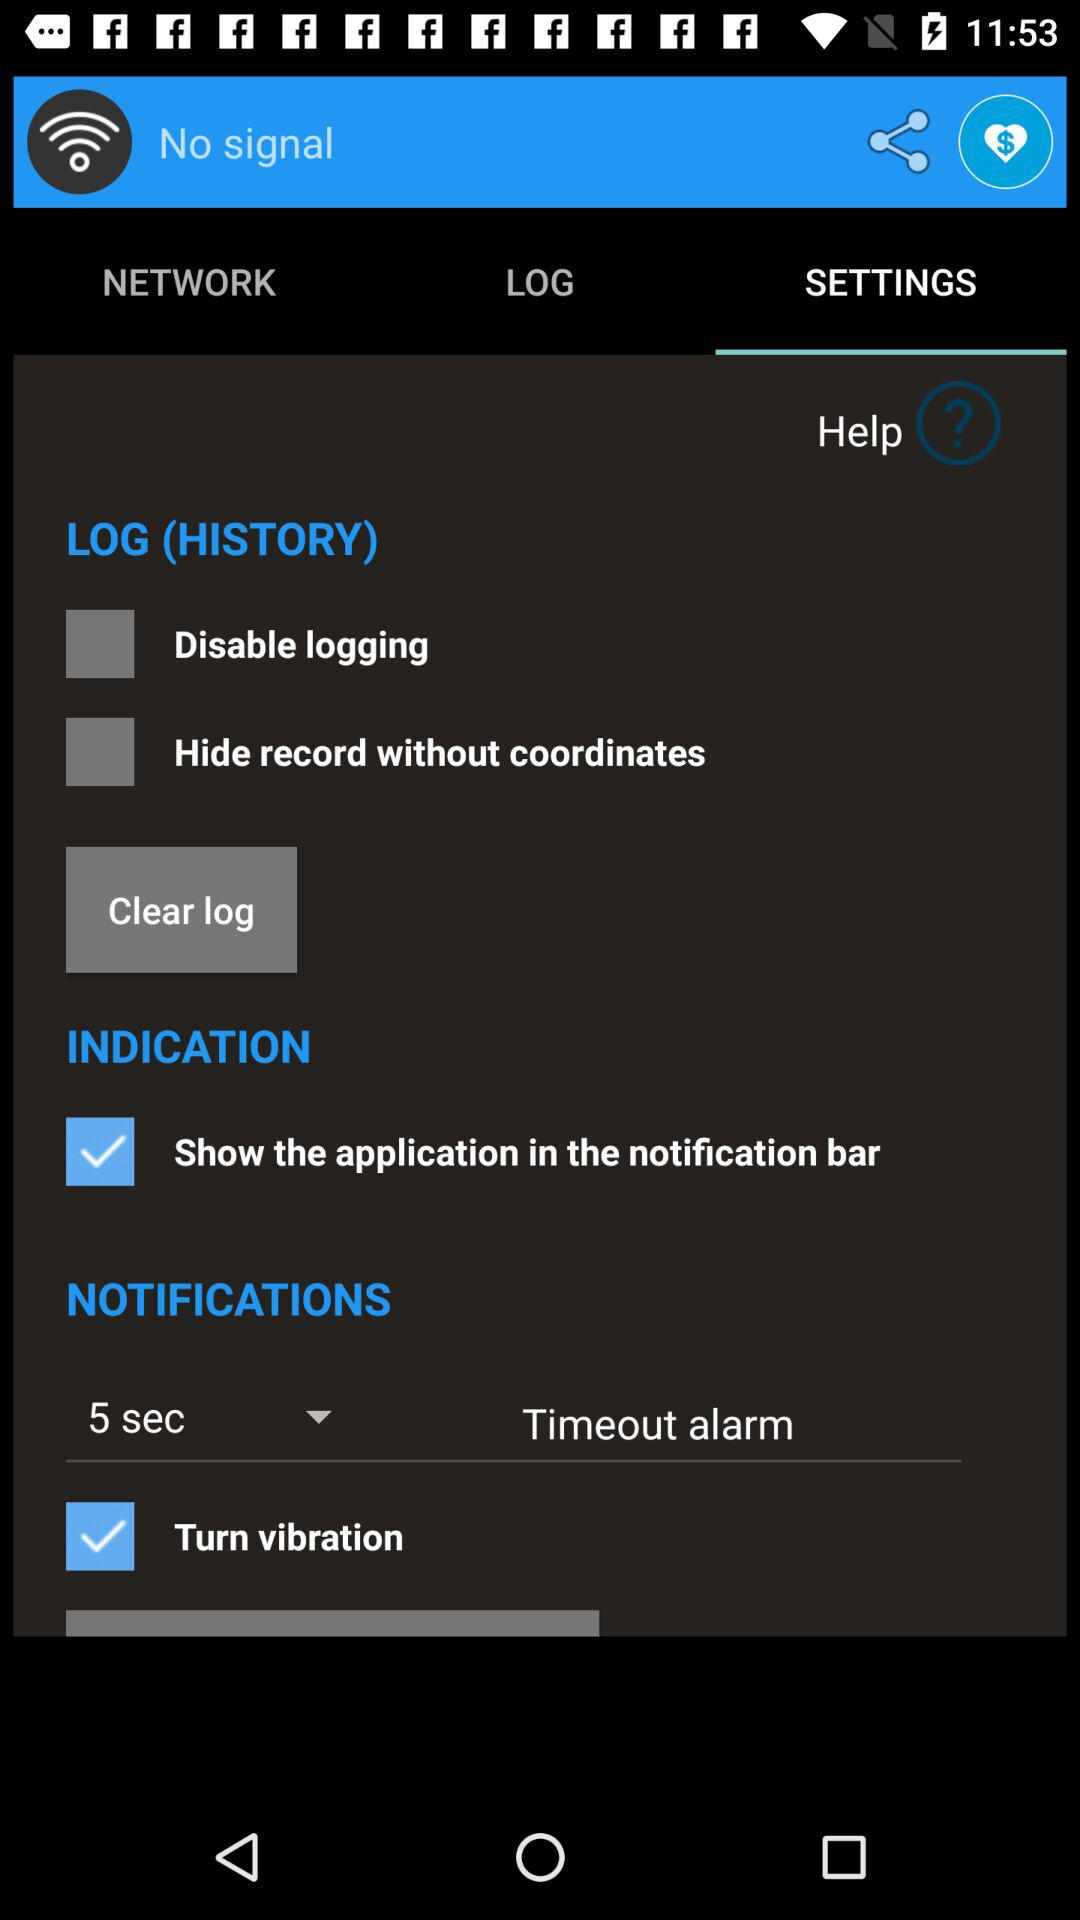What is the status of the indication?
When the provided information is insufficient, respond with <no answer>. <no answer> 